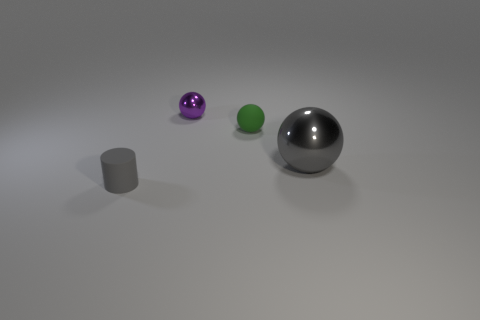Are there any large gray metallic objects?
Your response must be concise. Yes. There is a tiny shiny sphere; is its color the same as the tiny thing in front of the gray metallic sphere?
Provide a short and direct response. No. What is the color of the cylinder?
Give a very brief answer. Gray. Is there any other thing that is the same shape as the small green thing?
Keep it short and to the point. Yes. There is another tiny thing that is the same shape as the green matte object; what is its color?
Your answer should be compact. Purple. Does the tiny green thing have the same shape as the large metal object?
Your response must be concise. Yes. What number of cylinders are large brown things or gray objects?
Your answer should be very brief. 1. There is a ball that is made of the same material as the big object; what is its color?
Offer a terse response. Purple. Do the metallic sphere that is behind the gray sphere and the gray sphere have the same size?
Your response must be concise. No. Does the large gray ball have the same material as the gray thing on the left side of the big metal ball?
Make the answer very short. No. 